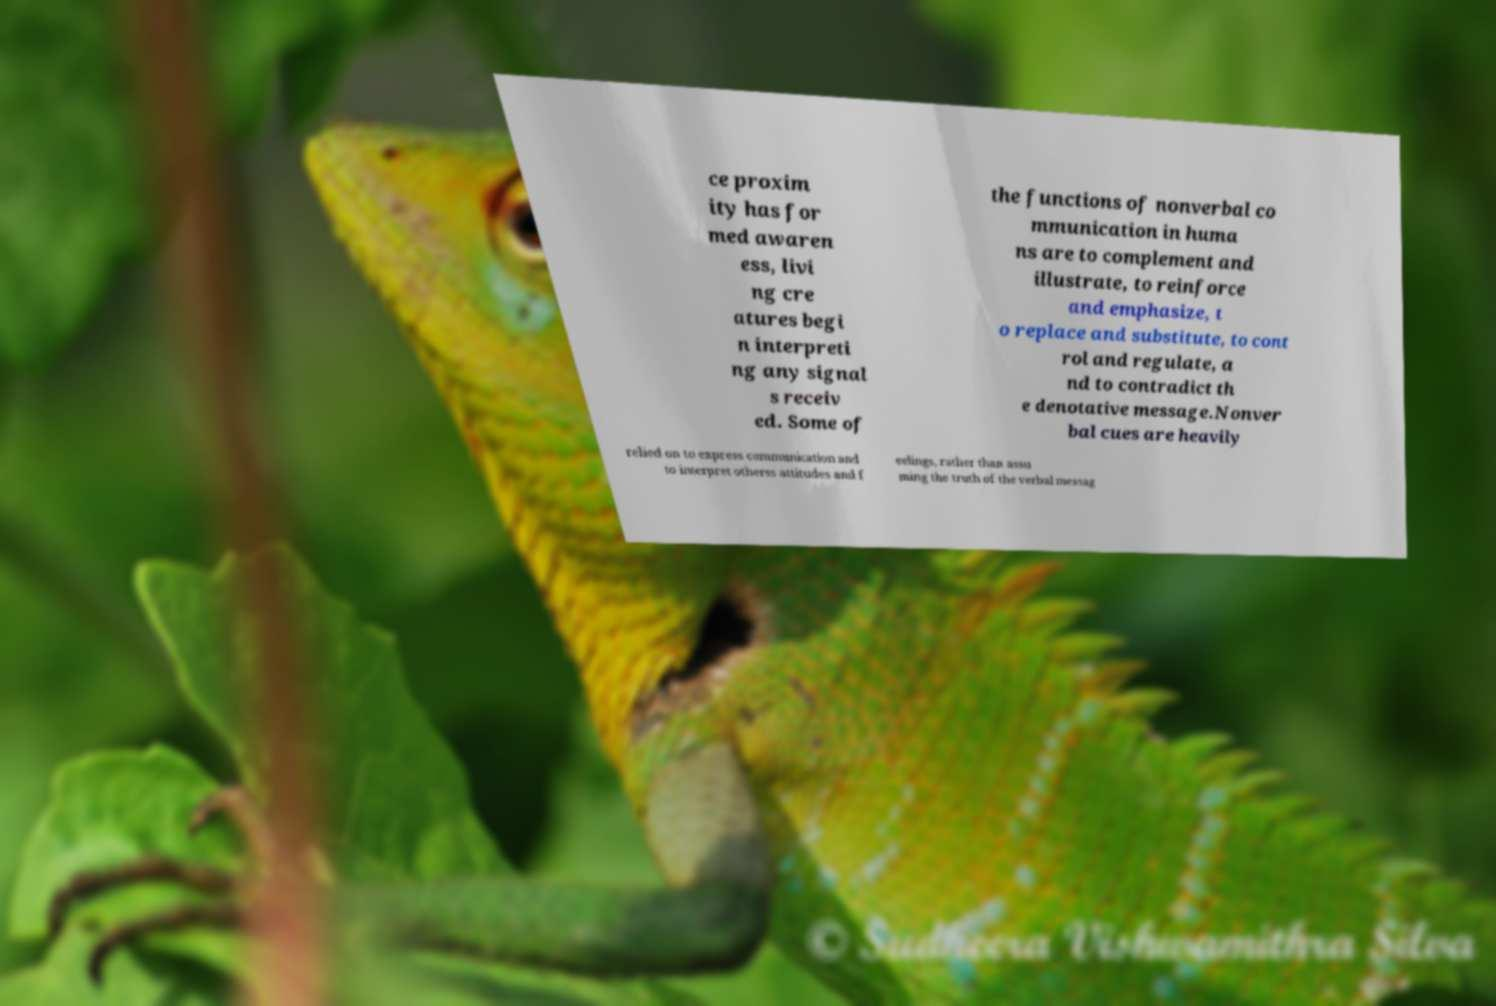Please identify and transcribe the text found in this image. ce proxim ity has for med awaren ess, livi ng cre atures begi n interpreti ng any signal s receiv ed. Some of the functions of nonverbal co mmunication in huma ns are to complement and illustrate, to reinforce and emphasize, t o replace and substitute, to cont rol and regulate, a nd to contradict th e denotative message.Nonver bal cues are heavily relied on to express communication and to interpret otherss attitudes and f eelings, rather than assu ming the truth of the verbal messag 